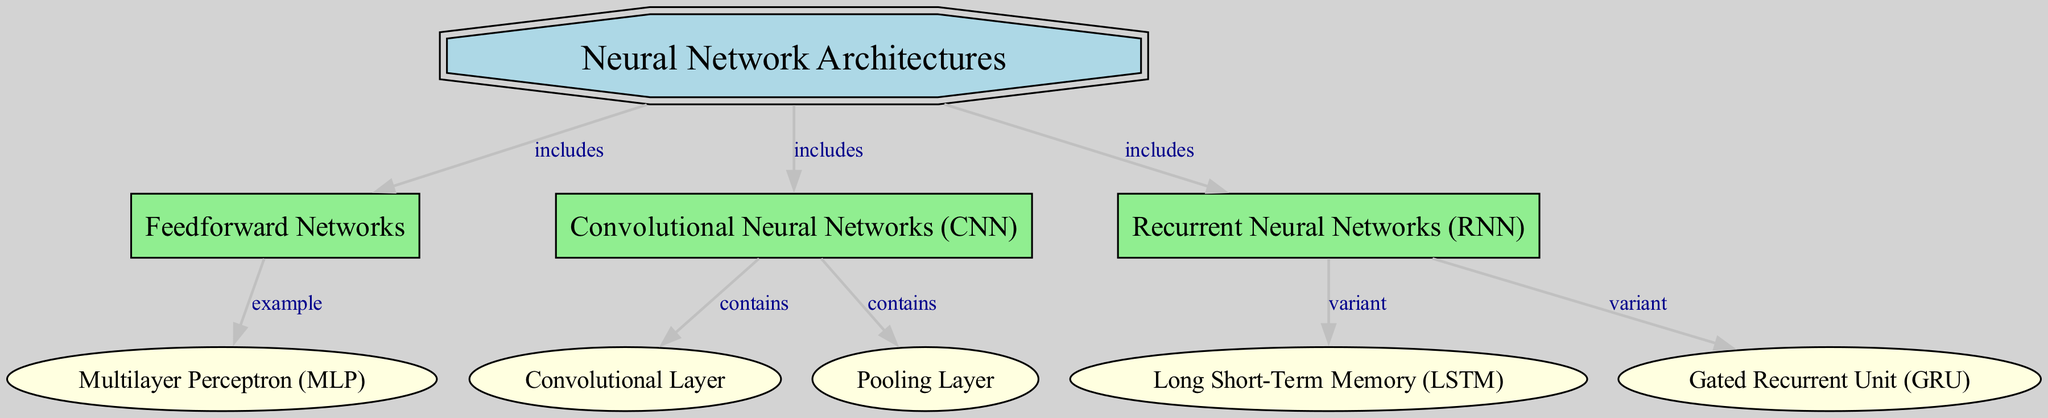What are the three main types of neural networks presented in the diagram? The diagram includes three main types of neural networks as nodes: Feedforward Networks, Convolutional Neural Networks (CNN), and Recurrent Neural Networks (RNN). These are directly connected to the main node labeled "Neural Network Architectures".
Answer: Feedforward Networks, Convolutional Neural Networks (CNN), Recurrent Neural Networks (RNN) Which architecture includes the Multilayer Perceptron? The Multilayer Perceptron (MLP) is an example of a Feedforward Network, as indicated by the edge connecting them labeled "example". Therefore, the Feedforward Network architecture includes the MLP.
Answer: Feedforward Networks How many variants of Recurrent Neural Networks are indicated in the diagram? The diagram shows two variants of Recurrent Neural Networks: Long Short-Term Memory (LSTM) and Gated Recurrent Unit (GRU). These two are connected directly to the RNN node, represented by "variant" edges.
Answer: 2 What layers are contained within Convolutional Neural Networks? The diagrams indicate that Convolutional Neural Networks contain two specific layers: Convolutional Layer and Pooling Layer. Both layers are directly connected to the CNN node, as shown by the "contains" edges.
Answer: Convolutional Layer, Pooling Layer How many nodes are there in total in the diagram? The diagram includes a total of eight nodes: one for the main "Neural Network Architectures", three for the main types (Feedforward, CNN, RNN), one for MLP, and two for the layers (Convolutional Layer, Pooling Layer) as well as two variants (LSTM, GRU). This totals to eight nodes.
Answer: 8 What type of layer is associated with Convolutional Neural Networks? The Convolutional Layer is specifically associated with Convolutional Neural Networks (CNN), as represented by a direct edge labeled "contains". This type of layer is critical for the function of CNNs in processing visual data.
Answer: Convolutional Layer 